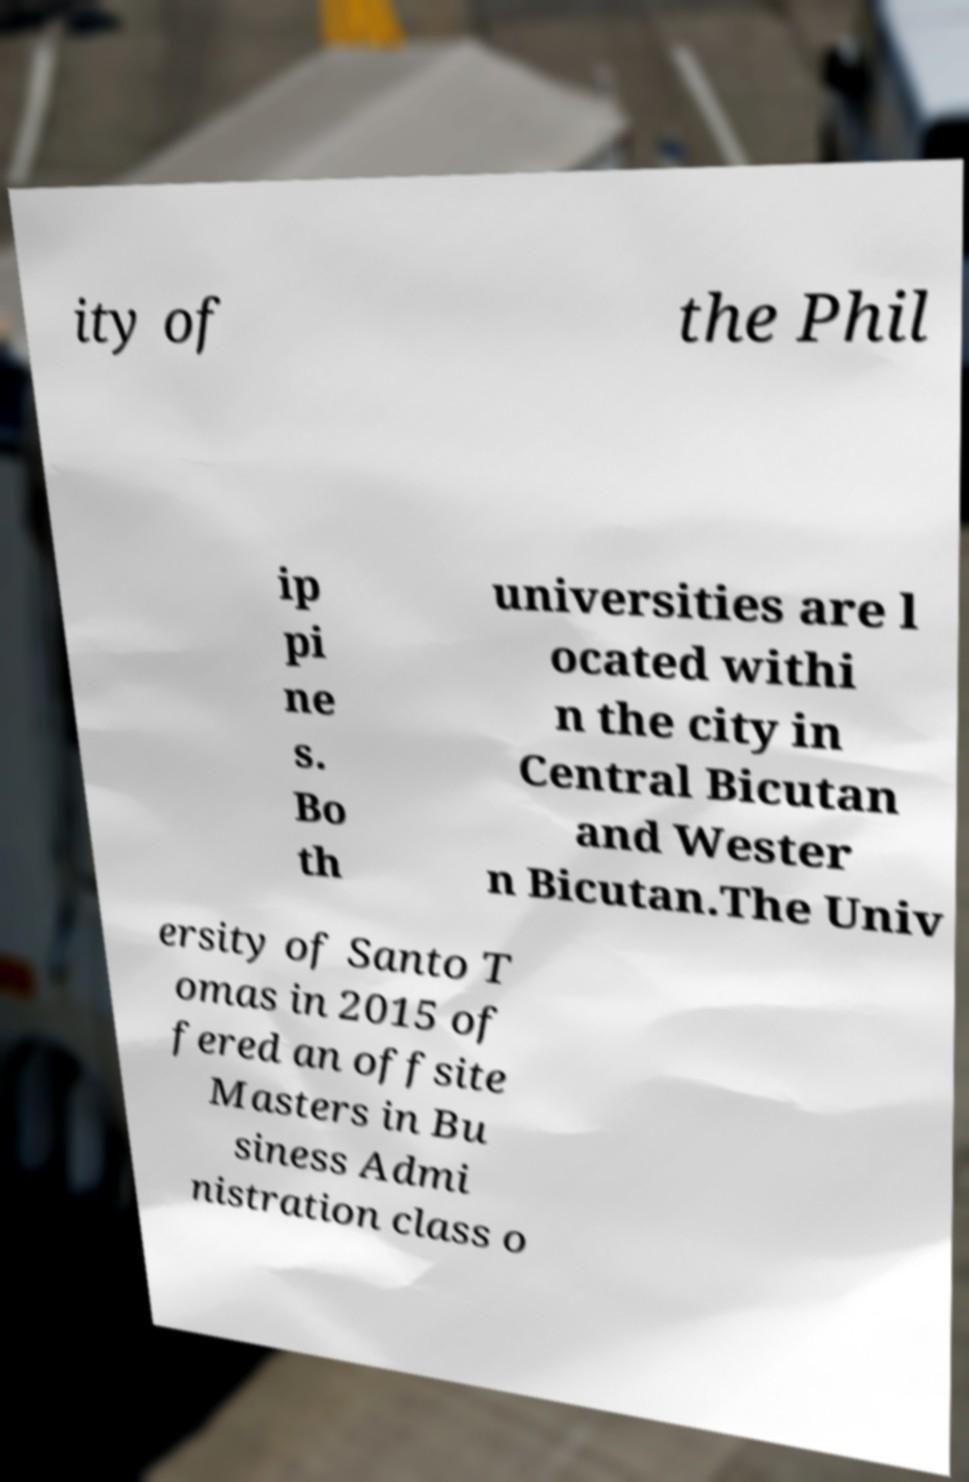Please read and relay the text visible in this image. What does it say? ity of the Phil ip pi ne s. Bo th universities are l ocated withi n the city in Central Bicutan and Wester n Bicutan.The Univ ersity of Santo T omas in 2015 of fered an offsite Masters in Bu siness Admi nistration class o 